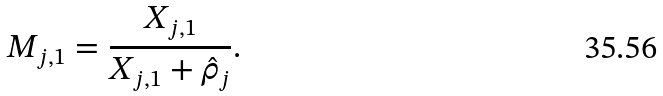Convert formula to latex. <formula><loc_0><loc_0><loc_500><loc_500>M _ { j , 1 } = \frac { X _ { j , 1 } } { X _ { j , 1 } + \hat { \rho } _ { j } } .</formula> 